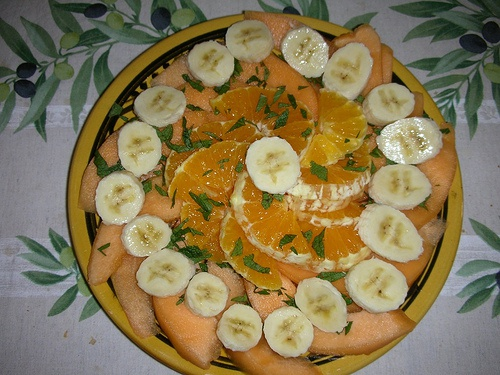Describe the objects in this image and their specific colors. I can see dining table in black, gray, and darkgreen tones, banana in black and tan tones, orange in black, olive, tan, and beige tones, and banana in black, beige, and tan tones in this image. 